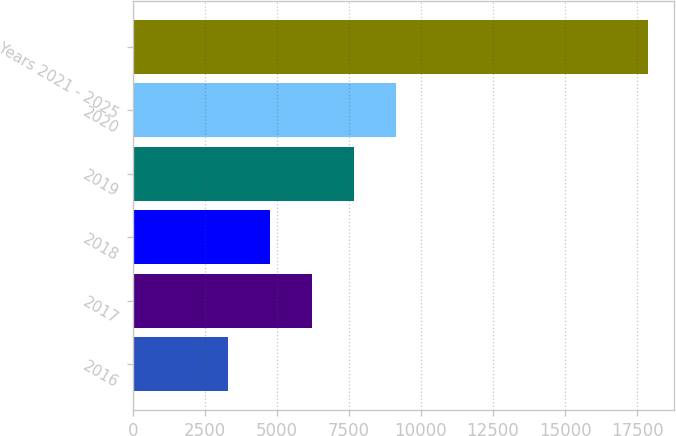Convert chart to OTSL. <chart><loc_0><loc_0><loc_500><loc_500><bar_chart><fcel>2016<fcel>2017<fcel>2018<fcel>2019<fcel>2020<fcel>Years 2021 - 2025<nl><fcel>3307<fcel>6222<fcel>4764.5<fcel>7679.5<fcel>9137<fcel>17882<nl></chart> 